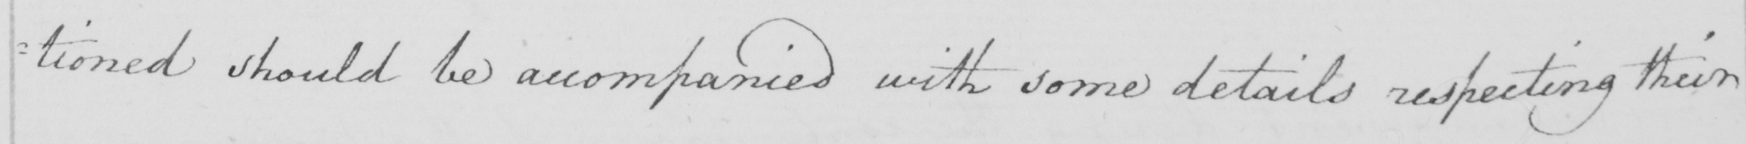Can you tell me what this handwritten text says? :tioned should be accompanied with some details respecting their 